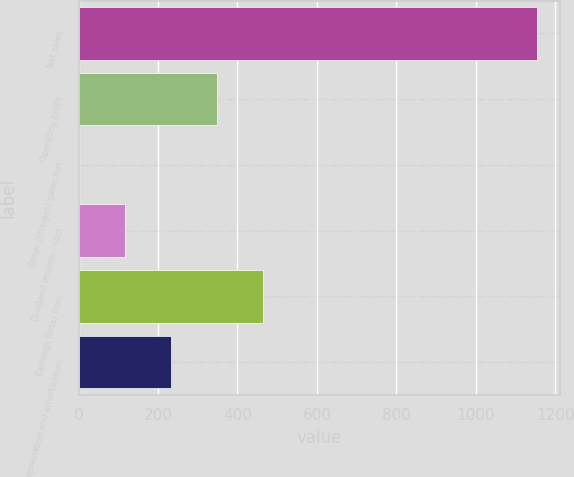Convert chart to OTSL. <chart><loc_0><loc_0><loc_500><loc_500><bar_chart><fcel>Net sales<fcel>Operating profit<fcel>Other (charges) gains net<fcel>Dividend income - cost<fcel>Earnings (loss) from<fcel>Depreciation and amortization<nl><fcel>1155<fcel>347.9<fcel>2<fcel>117.3<fcel>463.2<fcel>232.6<nl></chart> 